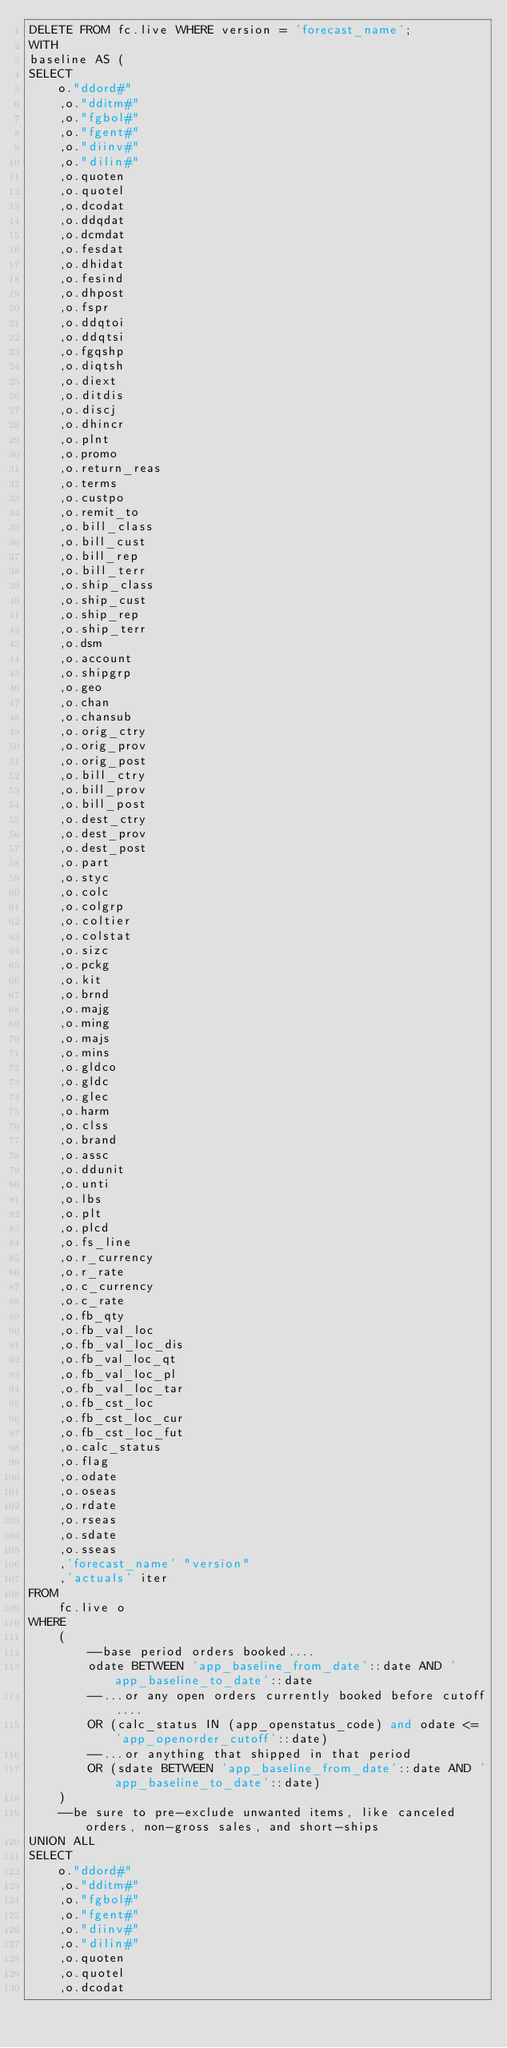<code> <loc_0><loc_0><loc_500><loc_500><_SQL_>DELETE FROM fc.live WHERE version = 'forecast_name';
WITH
baseline AS (
SELECT
    o."ddord#"
    ,o."dditm#"
    ,o."fgbol#"
    ,o."fgent#"
    ,o."diinv#"
    ,o."dilin#"
    ,o.quoten
    ,o.quotel
    ,o.dcodat
    ,o.ddqdat
    ,o.dcmdat
    ,o.fesdat
    ,o.dhidat
    ,o.fesind
    ,o.dhpost
    ,o.fspr
    ,o.ddqtoi
    ,o.ddqtsi
    ,o.fgqshp
    ,o.diqtsh
    ,o.diext
    ,o.ditdis
    ,o.discj
    ,o.dhincr
    ,o.plnt
    ,o.promo
    ,o.return_reas
    ,o.terms
    ,o.custpo
    ,o.remit_to
    ,o.bill_class
    ,o.bill_cust
    ,o.bill_rep
    ,o.bill_terr
    ,o.ship_class
    ,o.ship_cust
    ,o.ship_rep
    ,o.ship_terr
    ,o.dsm
    ,o.account
    ,o.shipgrp
    ,o.geo
    ,o.chan
    ,o.chansub
    ,o.orig_ctry
    ,o.orig_prov
    ,o.orig_post
    ,o.bill_ctry
    ,o.bill_prov
    ,o.bill_post
    ,o.dest_ctry
    ,o.dest_prov
    ,o.dest_post
    ,o.part
    ,o.styc
    ,o.colc
    ,o.colgrp
    ,o.coltier
    ,o.colstat
    ,o.sizc
    ,o.pckg
    ,o.kit
    ,o.brnd
    ,o.majg
    ,o.ming
    ,o.majs
    ,o.mins
    ,o.gldco
    ,o.gldc
    ,o.glec
    ,o.harm
    ,o.clss
    ,o.brand
    ,o.assc
    ,o.ddunit
    ,o.unti
    ,o.lbs
    ,o.plt
    ,o.plcd
    ,o.fs_line
    ,o.r_currency
    ,o.r_rate
    ,o.c_currency
    ,o.c_rate
    ,o.fb_qty
    ,o.fb_val_loc
    ,o.fb_val_loc_dis
    ,o.fb_val_loc_qt
    ,o.fb_val_loc_pl
    ,o.fb_val_loc_tar
    ,o.fb_cst_loc
    ,o.fb_cst_loc_cur
    ,o.fb_cst_loc_fut
    ,o.calc_status
    ,o.flag
    ,o.odate
    ,o.oseas
    ,o.rdate
    ,o.rseas
    ,o.sdate
    ,o.sseas
    ,'forecast_name' "version"
    ,'actuals' iter
FROM
    fc.live o
WHERE
    (
        --base period orders booked....
        odate BETWEEN 'app_baseline_from_date'::date AND 'app_baseline_to_date'::date
        --...or any open orders currently booked before cutoff....
        OR (calc_status IN (app_openstatus_code) and odate <= 'app_openorder_cutoff'::date)
        --...or anything that shipped in that period
        OR (sdate BETWEEN 'app_baseline_from_date'::date AND 'app_baseline_to_date'::date)
    )
    --be sure to pre-exclude unwanted items, like canceled orders, non-gross sales, and short-ships
UNION ALL
SELECT
    o."ddord#"
    ,o."dditm#"
    ,o."fgbol#"
    ,o."fgent#"
    ,o."diinv#"
    ,o."dilin#"
    ,o.quoten
    ,o.quotel
    ,o.dcodat</code> 